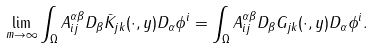Convert formula to latex. <formula><loc_0><loc_0><loc_500><loc_500>\lim _ { m \to \infty } \int _ { \Omega } A ^ { \alpha \beta } _ { i j } D _ { \beta } \bar { K } _ { j k } ( \cdot , y ) D _ { \alpha } \phi ^ { i } = \int _ { \Omega } A ^ { \alpha \beta } _ { i j } D _ { \beta } G _ { j k } ( \cdot , y ) D _ { \alpha } \phi ^ { i } .</formula> 